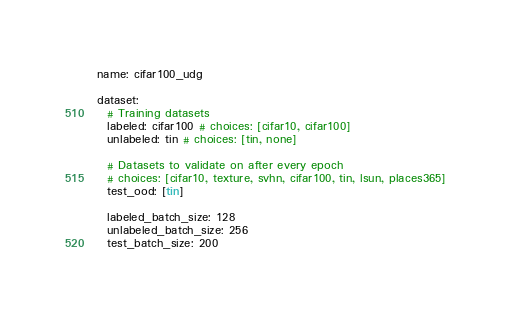<code> <loc_0><loc_0><loc_500><loc_500><_YAML_>name: cifar100_udg

dataset:
  # Training datasets
  labeled: cifar100 # choices: [cifar10, cifar100]
  unlabeled: tin # choices: [tin, none]

  # Datasets to validate on after every epoch
  # choices: [cifar10, texture, svhn, cifar100, tin, lsun, places365]
  test_ood: [tin]

  labeled_batch_size: 128
  unlabeled_batch_size: 256
  test_batch_size: 200
</code> 